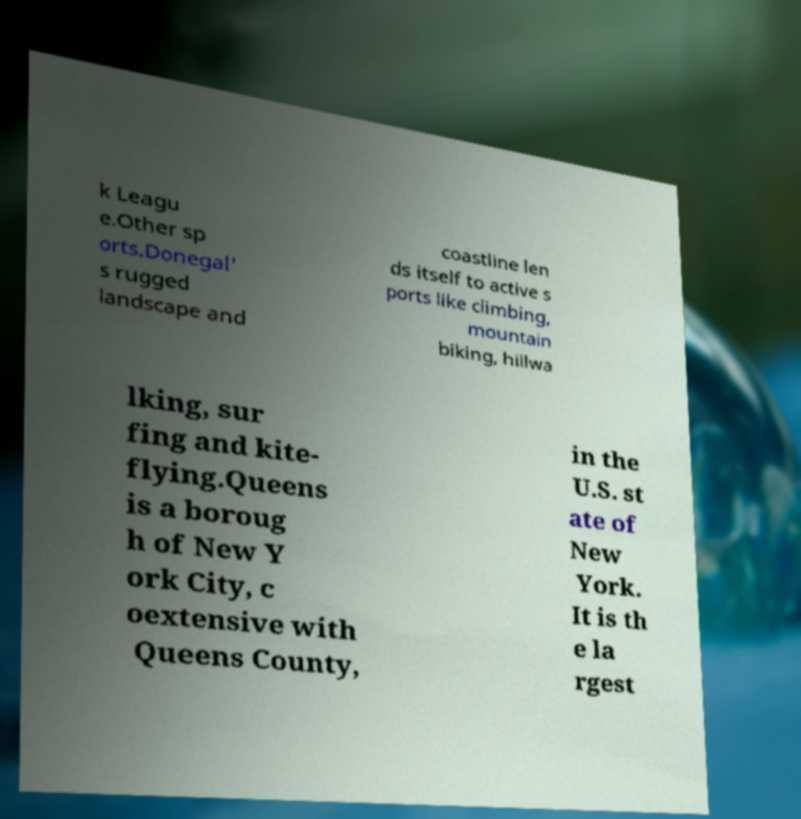Could you tell me more about Donegal and its popular sports? Donegal is known for its beautiful rugged landscapes, which make it a perfect place for various outdoor sports. Popular activities include mountain biking, hillwalking, and surfing, thanks to its challenging terrain and scenic coastlines. 